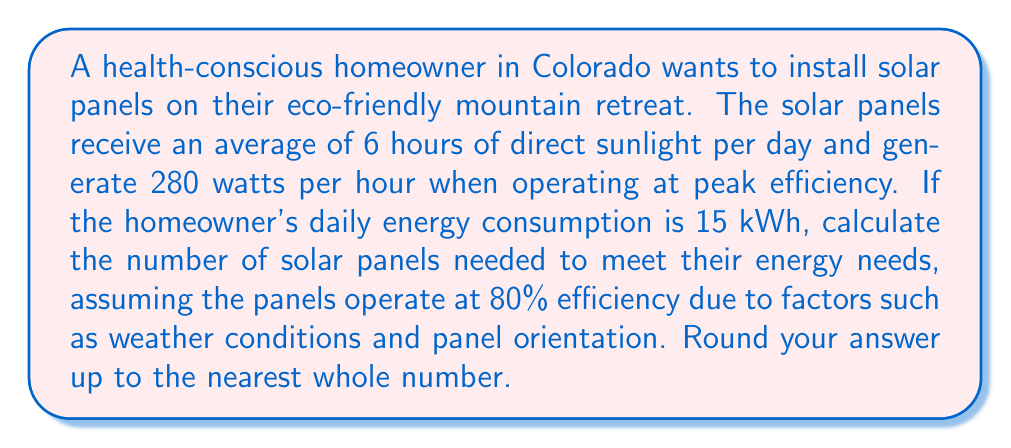Can you solve this math problem? Let's approach this problem step-by-step:

1. Calculate the actual energy generated by each panel per day:
   - Peak energy per panel = 280 watts = 0.28 kW
   - Hours of sunlight = 6 hours
   - Efficiency = 80% = 0.8
   - Energy per panel per day = $0.28 \text{ kW} \times 6 \text{ h} \times 0.8 = 1.344 \text{ kWh}$

2. Calculate the number of panels needed:
   - Daily energy consumption = 15 kWh
   - Number of panels = $\frac{\text{Daily energy consumption}}{\text{Energy per panel per day}}$
   - Number of panels = $\frac{15 \text{ kWh}}{1.344 \text{ kWh}} = 11.16$

3. Round up to the nearest whole number:
   - Number of panels needed = 12

Therefore, the homeowner needs 12 solar panels to meet their daily energy needs.
Answer: 12 panels 